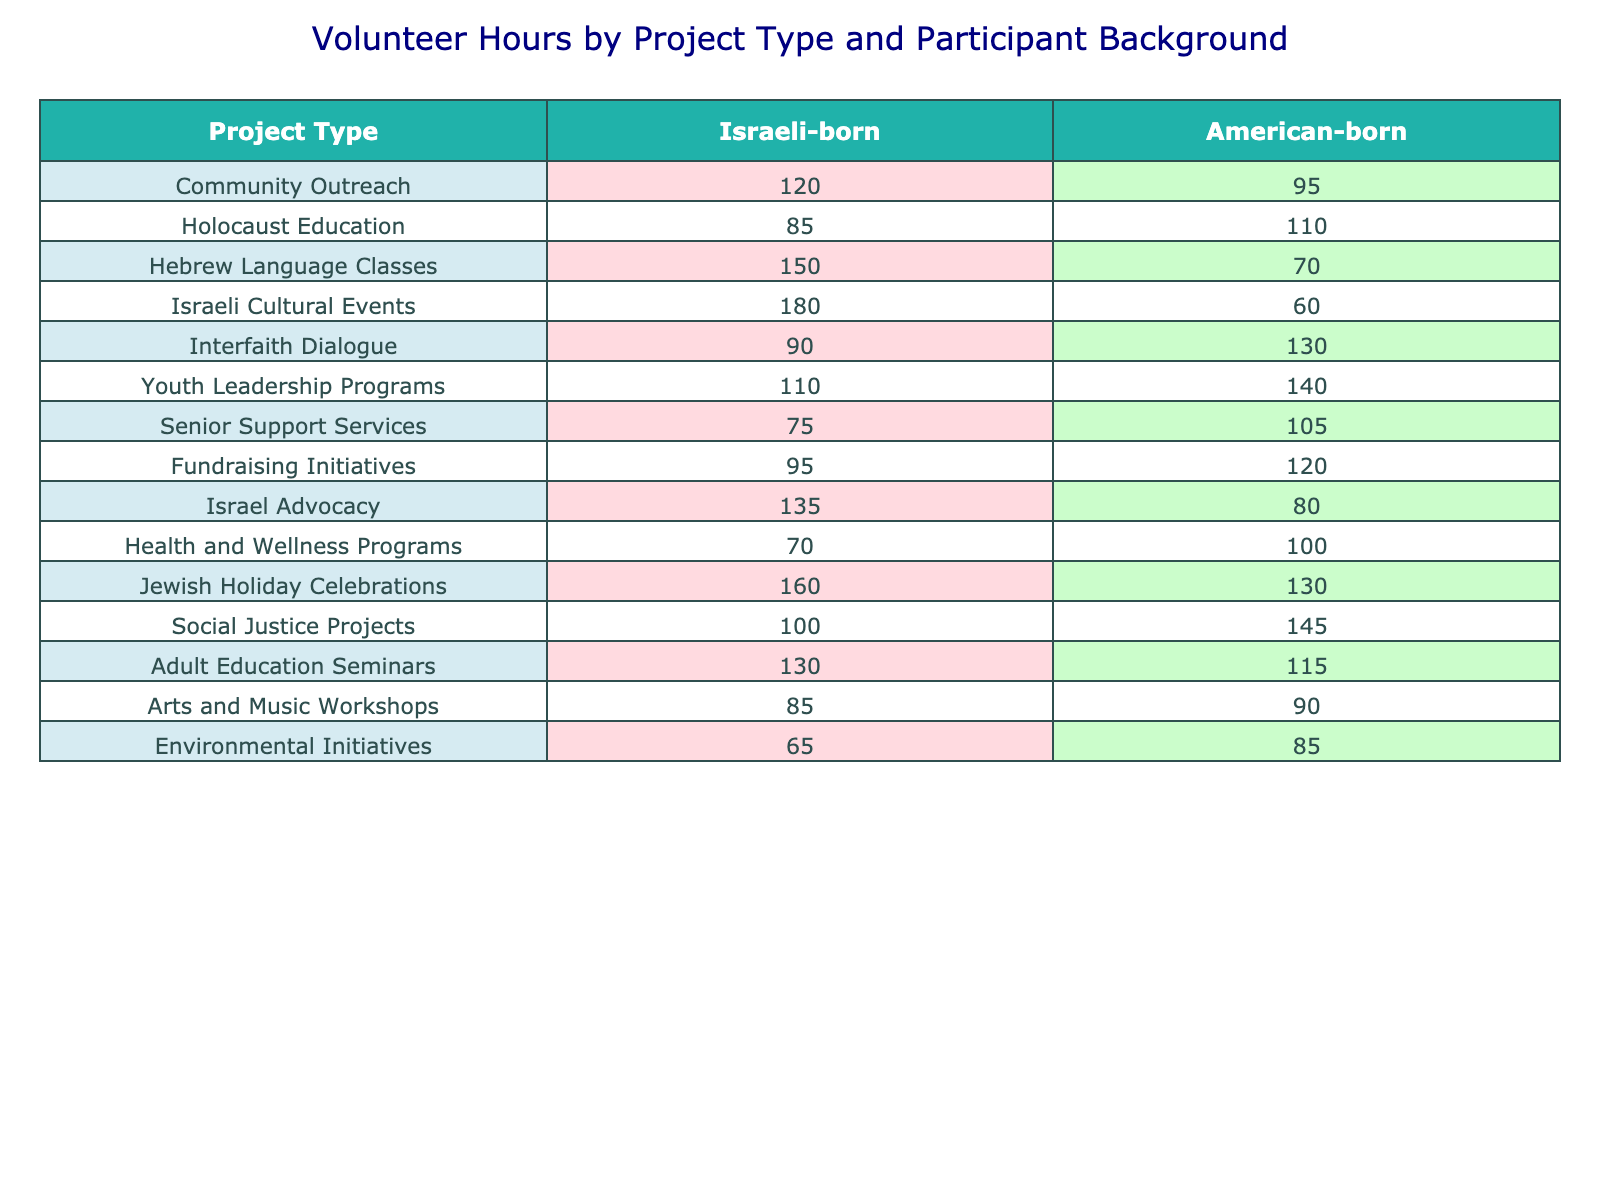What project type received the highest volunteer hours from Israeli-born participants? Looking at the table, the project type "Israeli Cultural Events" has the highest volunteer hours for Israeli-born participants, with a total of 180 hours.
Answer: Israeli Cultural Events What are the total volunteer hours contributed by American-born participants for all project types combined? To find the total volunteer hours, we sum the hours from the American-born column: 95 + 110 + 70 + 60 + 130 + 140 + 105 + 120 + 80 + 100 + 130 + 145 + 115 + 90 + 85 = 1,540.
Answer: 1540 In which project type did Israeli-born participants volunteer the least hours? The project type "Environmental Initiatives" received the least hours from Israeli-born participants, totaling 65 hours.
Answer: Environmental Initiatives Is it true that American-born participants volunteered more hours than Israeli-born participants in "Senior Support Services"? In the table, "Senior Support Services" shows 75 hours for Israeli-born and 105 hours for American-born participants. Therefore, it is true that American-born participants volunteered more.
Answer: Yes What is the difference in volunteer hours between "Holocaust Education" for Israeli-born and American-born participants? For "Holocaust Education," Israeli-born contributed 85 hours, and American-born contributed 110 hours. The difference is 110 - 85 = 25 hours.
Answer: 25 Which project type had the largest disparity in volunteer hours between Israeli-born and American-born participants? We calculate the absolute differences for each project type: Community Outreach (120 - 95 = 25), Holocaust Education (110 - 85 = 25), Hebrew Language Classes (150 - 70 = 80), Israeli Cultural Events (180 - 60 = 120), Interfaith Dialogue (130 - 90 = 40), Youth Leadership Programs (140 - 110 = 30), Senior Support Services (105 - 75 = 30), Fundraising Initiatives (120 - 95 = 25), Israel Advocacy (135 - 80 = 55), Health and Wellness Programs (100 - 70 = 30), Jewish Holiday Celebrations (160 - 130 = 30), Social Justice Projects (145 - 100 = 45), Adult Education Seminars (130 - 115 = 15), Arts and Music Workshops (90 - 85 = 5), and Environmental Initiatives (85 - 65 = 20). The largest disparity is for "Israeli Cultural Events", with a difference of 120 hours.
Answer: Israeli Cultural Events What is the average number of volunteer hours for American-born participants across all project types? The total volunteer hours for American-born participants is 1,540, and there are 15 project types. The average is 1,540/15 = 102.67, which we can round to 103.
Answer: 103 Did more Israeli-born or American-born participants volunteer for "Youth Leadership Programs"? The table shows that Israeli-born participants volunteered 110 hours, while American-born participants volunteered 140 hours for the same program. Thus, American-born participants volunteered more.
Answer: American-born participants How many project types had more than 100 volunteer hours from Israeli-born participants? From the table, the project types where Israeli-born participants contributed more than 100 hours are: Community Outreach (120), Hebrew Language Classes (150), Israeli Cultural Events (180), Youth Leadership Programs (110), Israel Advocacy (135), Jewish Holiday Celebrations (160), and Adult Education Seminars (130). This is a total of 7 project types.
Answer: 7 What is the total volunteer hours from Israeli-born participants among all cultural project types (Israeli Cultural Events, Jewish Holiday Celebrations, and Hebrew Language Classes)? We sum the volunteer hours for the specified cultural projects: Israeli Cultural Events (180) + Jewish Holiday Celebrations (160) + Hebrew Language Classes (150) = 490 hours.
Answer: 490 Which project type had the lowest total volunteer hours across both participant backgrounds? By comparing the total hours for each project type by adding hours from both backgrounds, we find: Community Outreach (215), Holocaust Education (195), Hebrew Language Classes (220), Israeli Cultural Events (240), Interfaith Dialogue (220), Youth Leadership Programs (250), Senior Support Services (180), Fundraising Initiatives (215), Israel Advocacy (215), Health and Wellness Programs (170), Jewish Holiday Celebrations (290), Social Justice Projects (245), Adult Education Seminars (245), Arts and Music Workshops (175), and Environmental Initiatives (150). The lowest total is for Environmental Initiatives, which has 150 hours.
Answer: Environmental Initiatives 